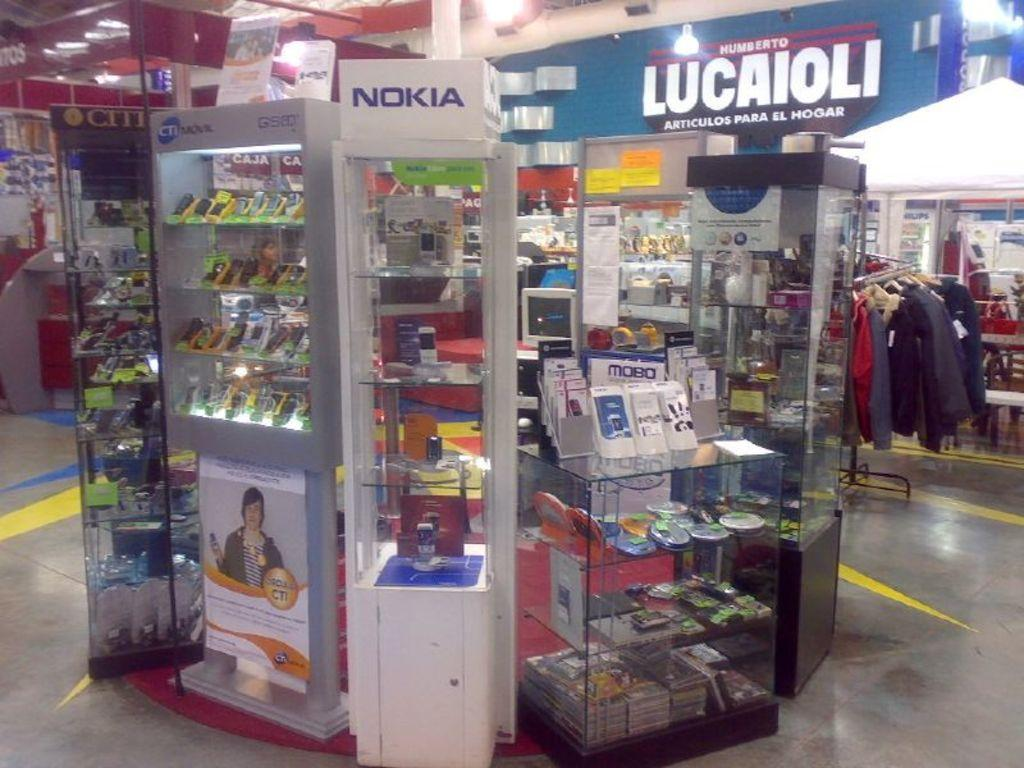Provide a one-sentence caption for the provided image. A Nokia phone display sits in a circle of other displays and product counters. 